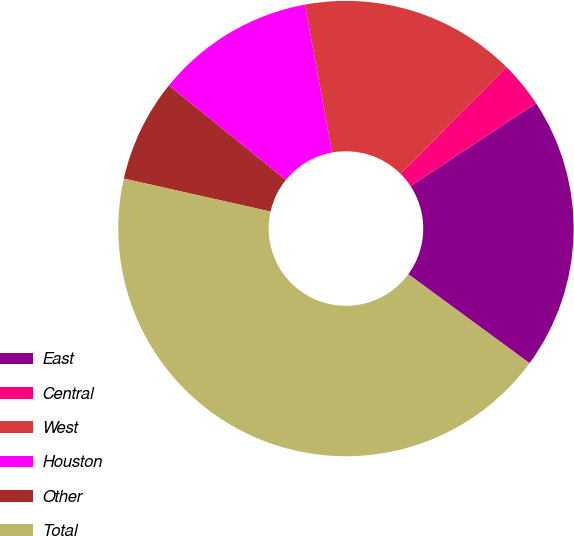Convert chart. <chart><loc_0><loc_0><loc_500><loc_500><pie_chart><fcel>East<fcel>Central<fcel>West<fcel>Houston<fcel>Other<fcel>Total<nl><fcel>19.34%<fcel>3.28%<fcel>15.33%<fcel>11.31%<fcel>7.29%<fcel>43.45%<nl></chart> 